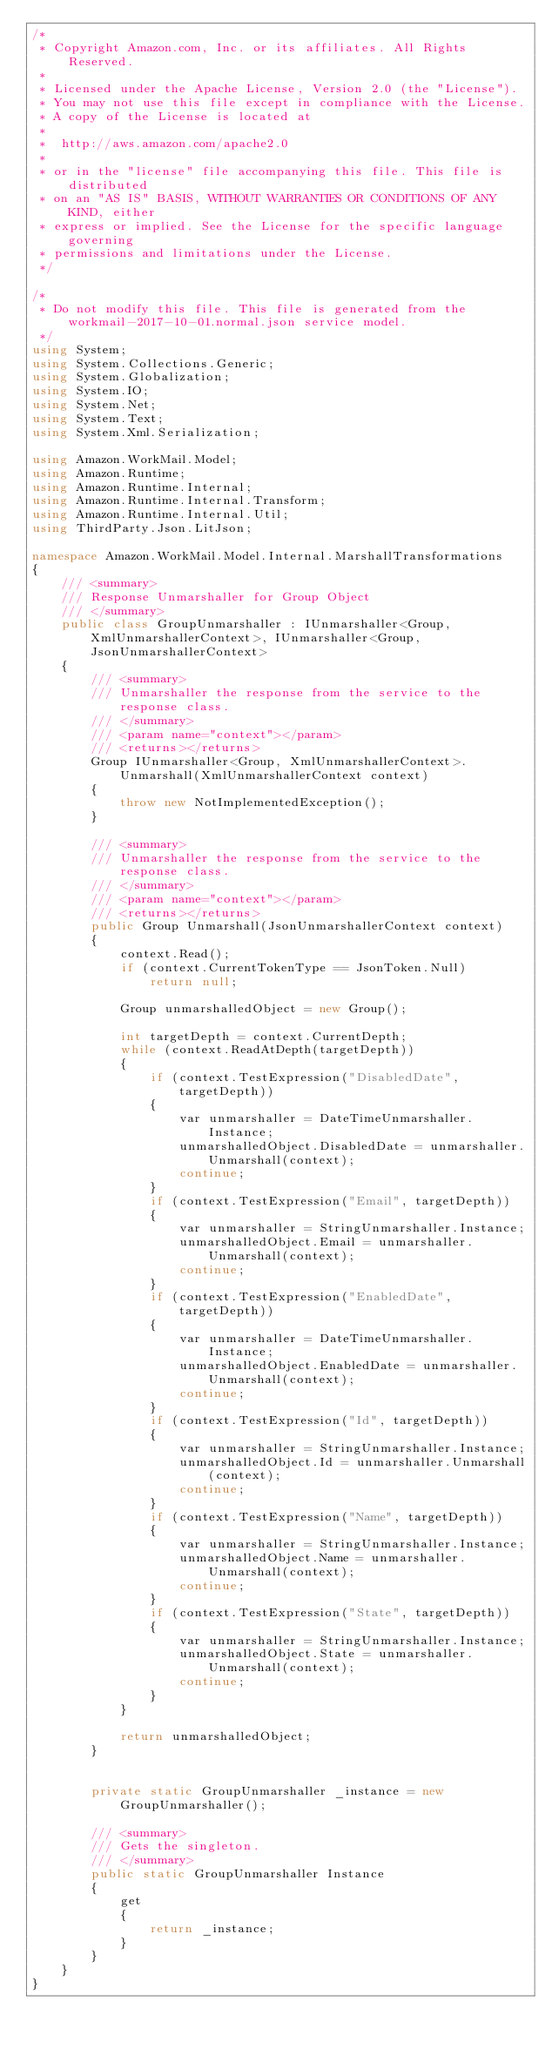Convert code to text. <code><loc_0><loc_0><loc_500><loc_500><_C#_>/*
 * Copyright Amazon.com, Inc. or its affiliates. All Rights Reserved.
 * 
 * Licensed under the Apache License, Version 2.0 (the "License").
 * You may not use this file except in compliance with the License.
 * A copy of the License is located at
 * 
 *  http://aws.amazon.com/apache2.0
 * 
 * or in the "license" file accompanying this file. This file is distributed
 * on an "AS IS" BASIS, WITHOUT WARRANTIES OR CONDITIONS OF ANY KIND, either
 * express or implied. See the License for the specific language governing
 * permissions and limitations under the License.
 */

/*
 * Do not modify this file. This file is generated from the workmail-2017-10-01.normal.json service model.
 */
using System;
using System.Collections.Generic;
using System.Globalization;
using System.IO;
using System.Net;
using System.Text;
using System.Xml.Serialization;

using Amazon.WorkMail.Model;
using Amazon.Runtime;
using Amazon.Runtime.Internal;
using Amazon.Runtime.Internal.Transform;
using Amazon.Runtime.Internal.Util;
using ThirdParty.Json.LitJson;

namespace Amazon.WorkMail.Model.Internal.MarshallTransformations
{
    /// <summary>
    /// Response Unmarshaller for Group Object
    /// </summary>  
    public class GroupUnmarshaller : IUnmarshaller<Group, XmlUnmarshallerContext>, IUnmarshaller<Group, JsonUnmarshallerContext>
    {
        /// <summary>
        /// Unmarshaller the response from the service to the response class.
        /// </summary>  
        /// <param name="context"></param>
        /// <returns></returns>
        Group IUnmarshaller<Group, XmlUnmarshallerContext>.Unmarshall(XmlUnmarshallerContext context)
        {
            throw new NotImplementedException();
        }

        /// <summary>
        /// Unmarshaller the response from the service to the response class.
        /// </summary>  
        /// <param name="context"></param>
        /// <returns></returns>
        public Group Unmarshall(JsonUnmarshallerContext context)
        {
            context.Read();
            if (context.CurrentTokenType == JsonToken.Null) 
                return null;

            Group unmarshalledObject = new Group();
        
            int targetDepth = context.CurrentDepth;
            while (context.ReadAtDepth(targetDepth))
            {
                if (context.TestExpression("DisabledDate", targetDepth))
                {
                    var unmarshaller = DateTimeUnmarshaller.Instance;
                    unmarshalledObject.DisabledDate = unmarshaller.Unmarshall(context);
                    continue;
                }
                if (context.TestExpression("Email", targetDepth))
                {
                    var unmarshaller = StringUnmarshaller.Instance;
                    unmarshalledObject.Email = unmarshaller.Unmarshall(context);
                    continue;
                }
                if (context.TestExpression("EnabledDate", targetDepth))
                {
                    var unmarshaller = DateTimeUnmarshaller.Instance;
                    unmarshalledObject.EnabledDate = unmarshaller.Unmarshall(context);
                    continue;
                }
                if (context.TestExpression("Id", targetDepth))
                {
                    var unmarshaller = StringUnmarshaller.Instance;
                    unmarshalledObject.Id = unmarshaller.Unmarshall(context);
                    continue;
                }
                if (context.TestExpression("Name", targetDepth))
                {
                    var unmarshaller = StringUnmarshaller.Instance;
                    unmarshalledObject.Name = unmarshaller.Unmarshall(context);
                    continue;
                }
                if (context.TestExpression("State", targetDepth))
                {
                    var unmarshaller = StringUnmarshaller.Instance;
                    unmarshalledObject.State = unmarshaller.Unmarshall(context);
                    continue;
                }
            }
          
            return unmarshalledObject;
        }


        private static GroupUnmarshaller _instance = new GroupUnmarshaller();        

        /// <summary>
        /// Gets the singleton.
        /// </summary>  
        public static GroupUnmarshaller Instance
        {
            get
            {
                return _instance;
            }
        }
    }
}</code> 